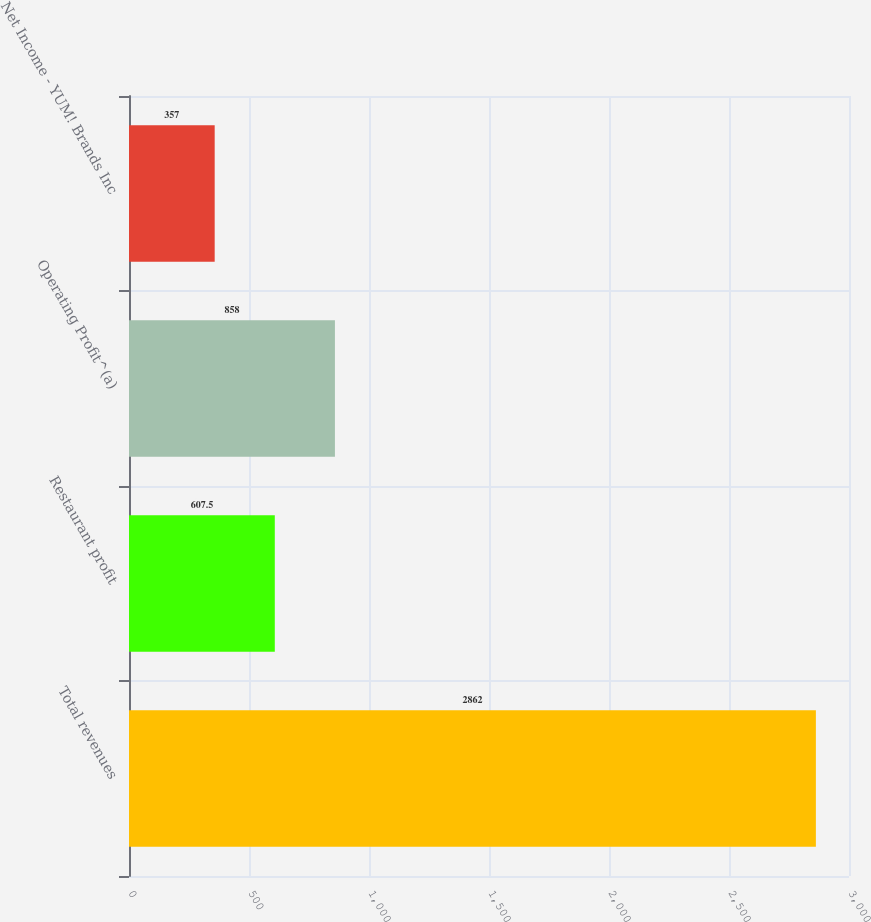Convert chart. <chart><loc_0><loc_0><loc_500><loc_500><bar_chart><fcel>Total revenues<fcel>Restaurant profit<fcel>Operating Profit^(a)<fcel>Net Income - YUM! Brands Inc<nl><fcel>2862<fcel>607.5<fcel>858<fcel>357<nl></chart> 